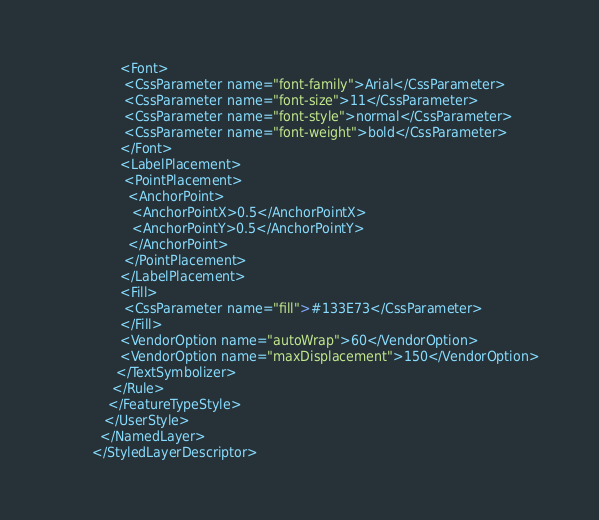<code> <loc_0><loc_0><loc_500><loc_500><_Scheme_>		       <Font>
		        <CssParameter name="font-family">Arial</CssParameter>
		        <CssParameter name="font-size">11</CssParameter>
		        <CssParameter name="font-style">normal</CssParameter>
		        <CssParameter name="font-weight">bold</CssParameter>
		       </Font>
		       <LabelPlacement>
		        <PointPlacement>
		         <AnchorPoint>
		          <AnchorPointX>0.5</AnchorPointX>
		          <AnchorPointY>0.5</AnchorPointY>
		         </AnchorPoint>
		        </PointPlacement>
		       </LabelPlacement>
		       <Fill>
		        <CssParameter name="fill">#133E73</CssParameter>
		       </Fill>
		       <VendorOption name="autoWrap">60</VendorOption>
		       <VendorOption name="maxDisplacement">150</VendorOption>
		      </TextSymbolizer>
		     </Rule>
		    </FeatureTypeStyle>
		   </UserStyle>
		  </NamedLayer>
		</StyledLayerDescriptor>
</code> 